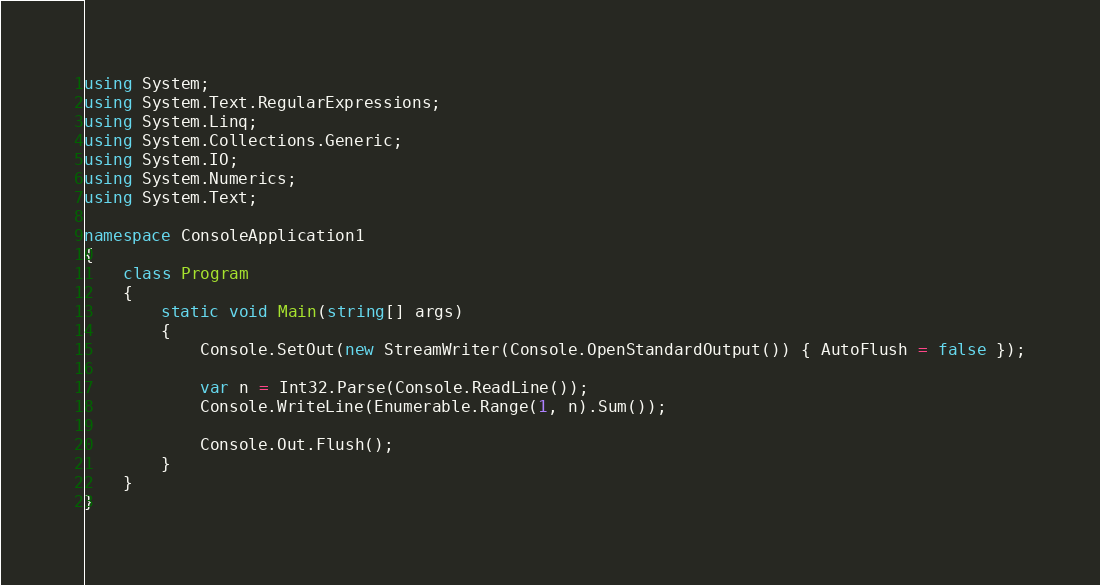Convert code to text. <code><loc_0><loc_0><loc_500><loc_500><_C#_>using System;
using System.Text.RegularExpressions;
using System.Linq;
using System.Collections.Generic;
using System.IO;
using System.Numerics;
using System.Text;

namespace ConsoleApplication1
{
    class Program
    {
        static void Main(string[] args)
        {
            Console.SetOut(new StreamWriter(Console.OpenStandardOutput()) { AutoFlush = false });

            var n = Int32.Parse(Console.ReadLine());
            Console.WriteLine(Enumerable.Range(1, n).Sum());

            Console.Out.Flush();
        }
    }
}</code> 